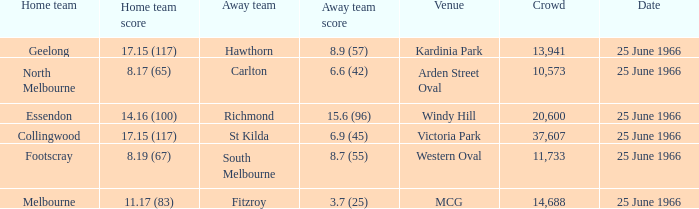When a home team tallied 1 St Kilda. 